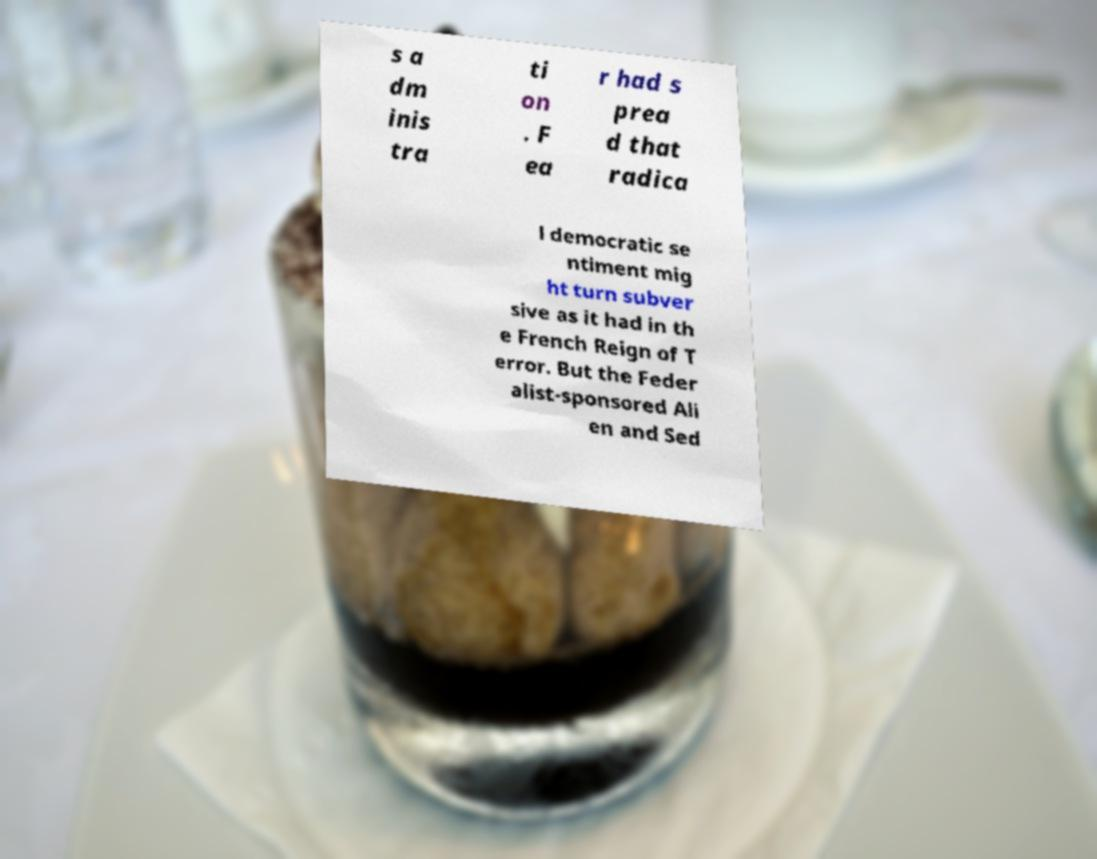Can you read and provide the text displayed in the image?This photo seems to have some interesting text. Can you extract and type it out for me? s a dm inis tra ti on . F ea r had s prea d that radica l democratic se ntiment mig ht turn subver sive as it had in th e French Reign of T error. But the Feder alist-sponsored Ali en and Sed 